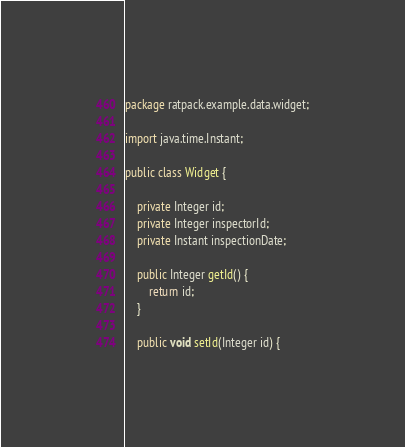<code> <loc_0><loc_0><loc_500><loc_500><_Java_>package ratpack.example.data.widget;

import java.time.Instant;

public class Widget {

    private Integer id;
    private Integer inspectorId;
    private Instant inspectionDate;

    public Integer getId() {
        return id;
    }

    public void setId(Integer id) {</code> 